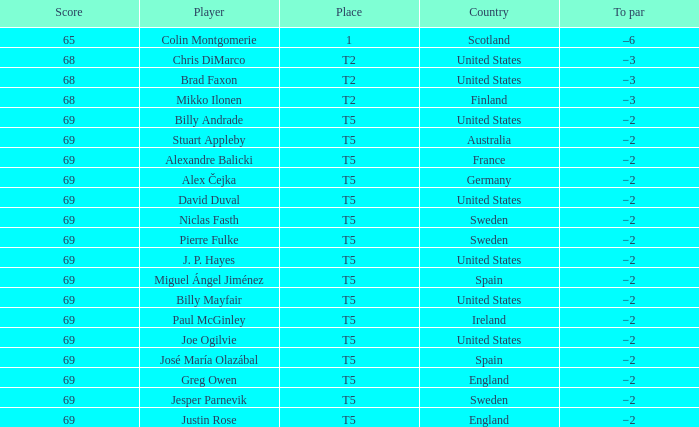What place did Paul McGinley finish in? T5. 